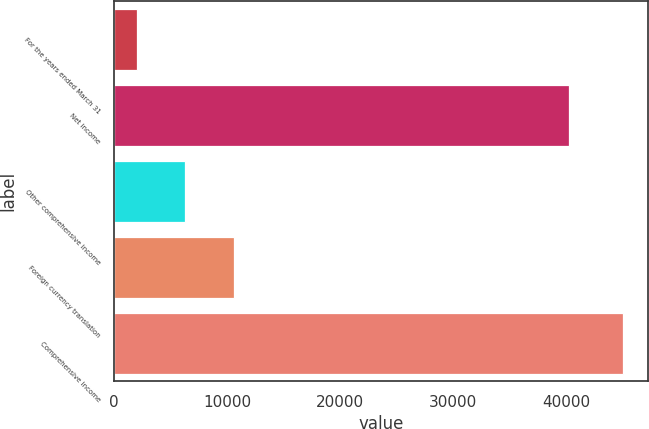Convert chart to OTSL. <chart><loc_0><loc_0><loc_500><loc_500><bar_chart><fcel>For the years ended March 31<fcel>Net income<fcel>Other comprehensive income<fcel>Foreign currency translation<fcel>Comprehensive income<nl><fcel>2006<fcel>40251<fcel>6305.6<fcel>10605.2<fcel>45002<nl></chart> 